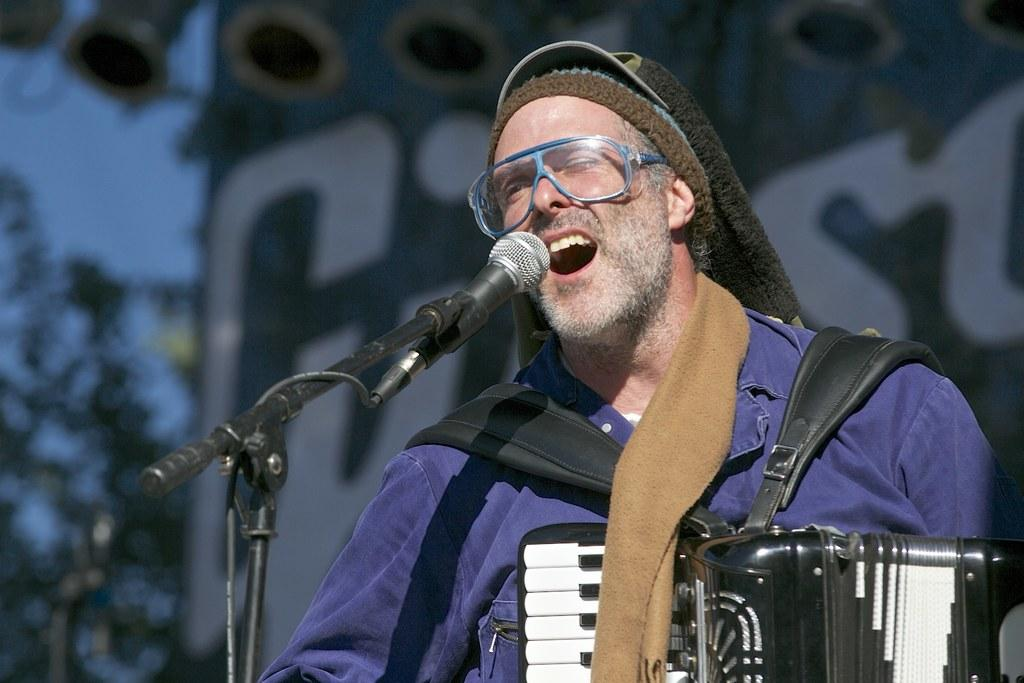What is the main subject of the image? There is a person in the image. What is the person wearing on their head? The person is wearing a cap. What is the person doing in the image? The person is playing a musical instrument. What object is the person standing in front of? The person is in front of a microphone. What type of natural element can be seen in the image? There is a tree visible in the image. Can you tell me how many cows are visible in the image? There are no cows present in the image; it features a person playing a musical instrument in front of a microphone. 